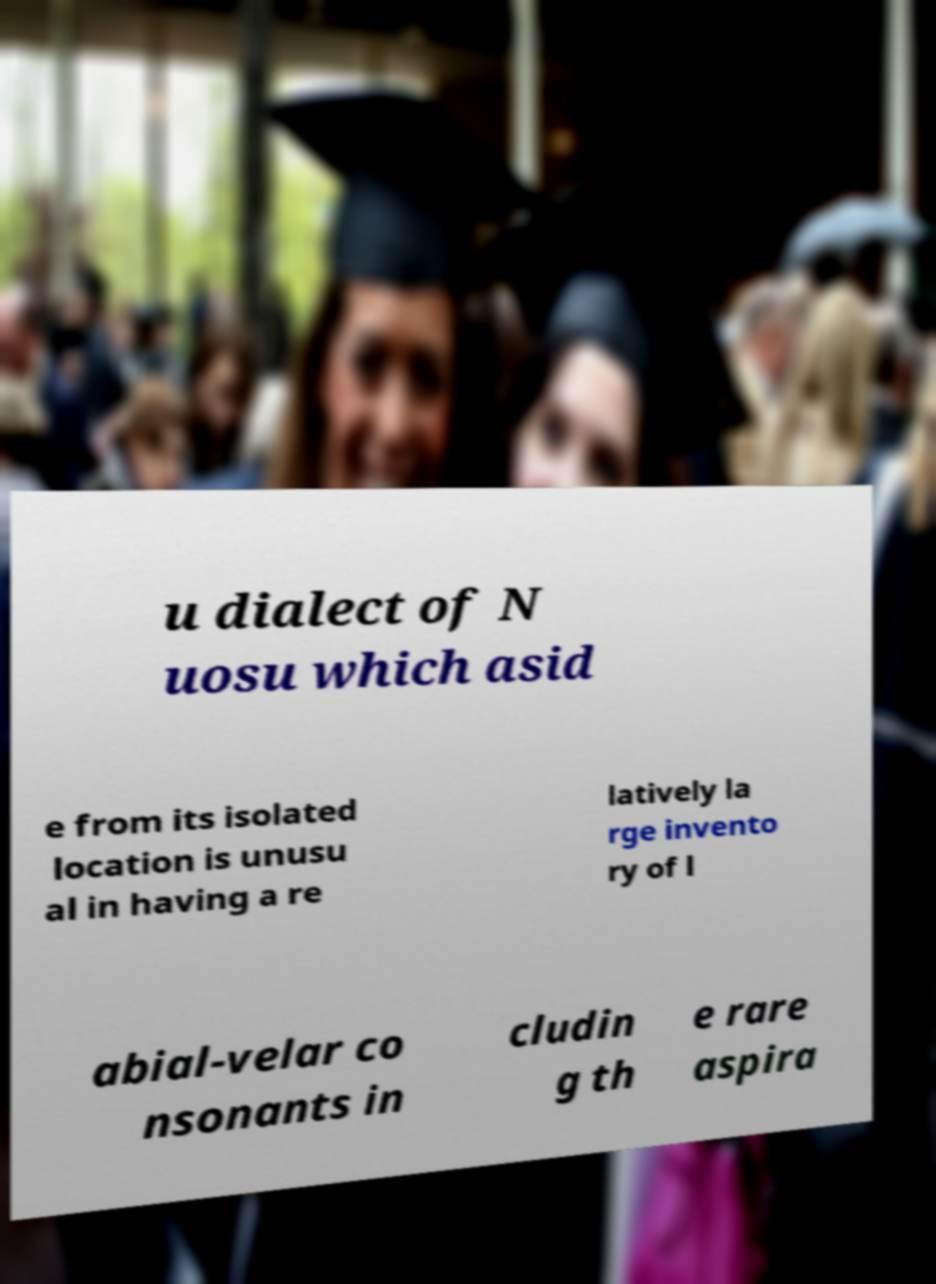What messages or text are displayed in this image? I need them in a readable, typed format. u dialect of N uosu which asid e from its isolated location is unusu al in having a re latively la rge invento ry of l abial-velar co nsonants in cludin g th e rare aspira 